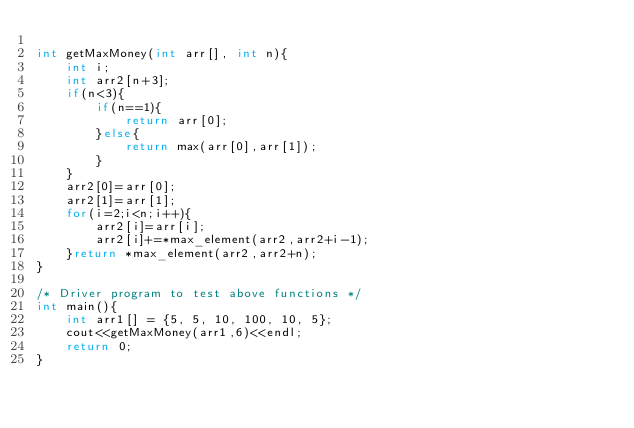<code> <loc_0><loc_0><loc_500><loc_500><_C++_>
int getMaxMoney(int arr[], int n){
    int i;
    int arr2[n+3];
    if(n<3){
        if(n==1){
            return arr[0];  
        }else{
            return max(arr[0],arr[1]);
        }
    }
    arr2[0]=arr[0];
    arr2[1]=arr[1];
    for(i=2;i<n;i++){
        arr2[i]=arr[i];
        arr2[i]+=*max_element(arr2,arr2+i-1);
    }return *max_element(arr2,arr2+n);
}

/* Driver program to test above functions */
int main(){
    int arr1[] = {5, 5, 10, 100, 10, 5};
    cout<<getMaxMoney(arr1,6)<<endl;
    return 0;
}</code> 